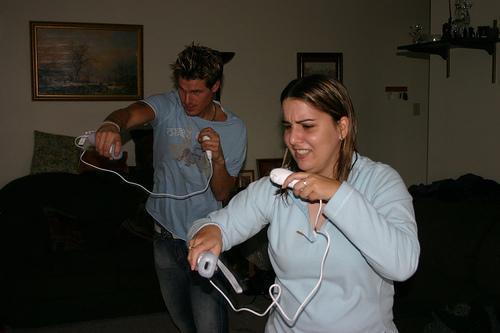How many people are shown?
Give a very brief answer. 2. How many pictures on the wall?
Give a very brief answer. 2. How many people are there?
Give a very brief answer. 2. How many couches can be seen?
Give a very brief answer. 2. How many of the motorcycles are blue?
Give a very brief answer. 0. 